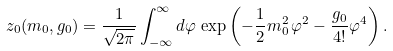<formula> <loc_0><loc_0><loc_500><loc_500>z _ { 0 } ( m _ { 0 } , g _ { 0 } ) = \frac { 1 } { \sqrt { 2 \pi } } \int _ { - \infty } ^ { \infty } d \varphi \, \exp \left ( - \frac { 1 } { 2 } m _ { 0 } ^ { 2 } \, \varphi ^ { 2 } - \frac { g _ { 0 } } { 4 ! } \varphi ^ { 4 } \right ) .</formula> 